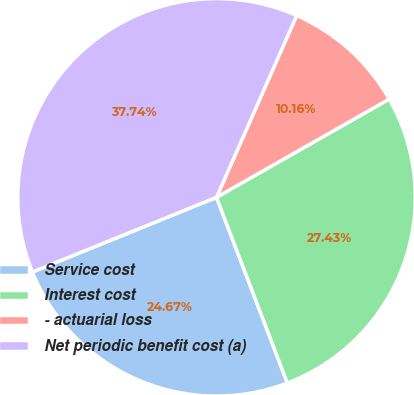<chart> <loc_0><loc_0><loc_500><loc_500><pie_chart><fcel>Service cost<fcel>Interest cost<fcel>- actuarial loss<fcel>Net periodic benefit cost (a)<nl><fcel>24.67%<fcel>27.43%<fcel>10.16%<fcel>37.74%<nl></chart> 